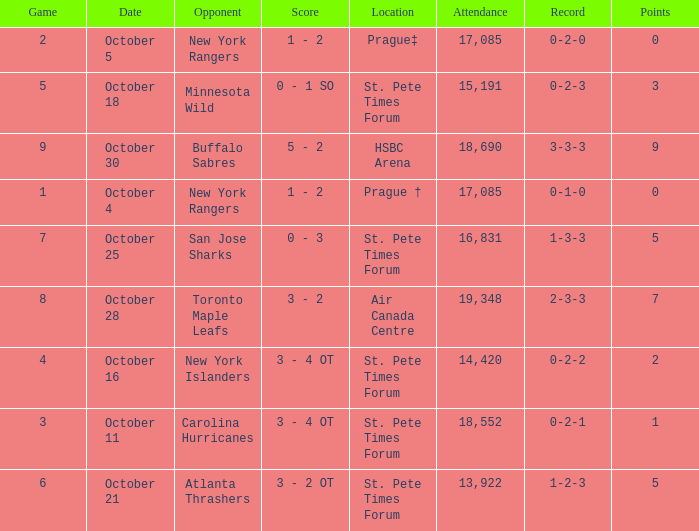What was the attendance when their record stood at 0-2-2? 14420.0. 